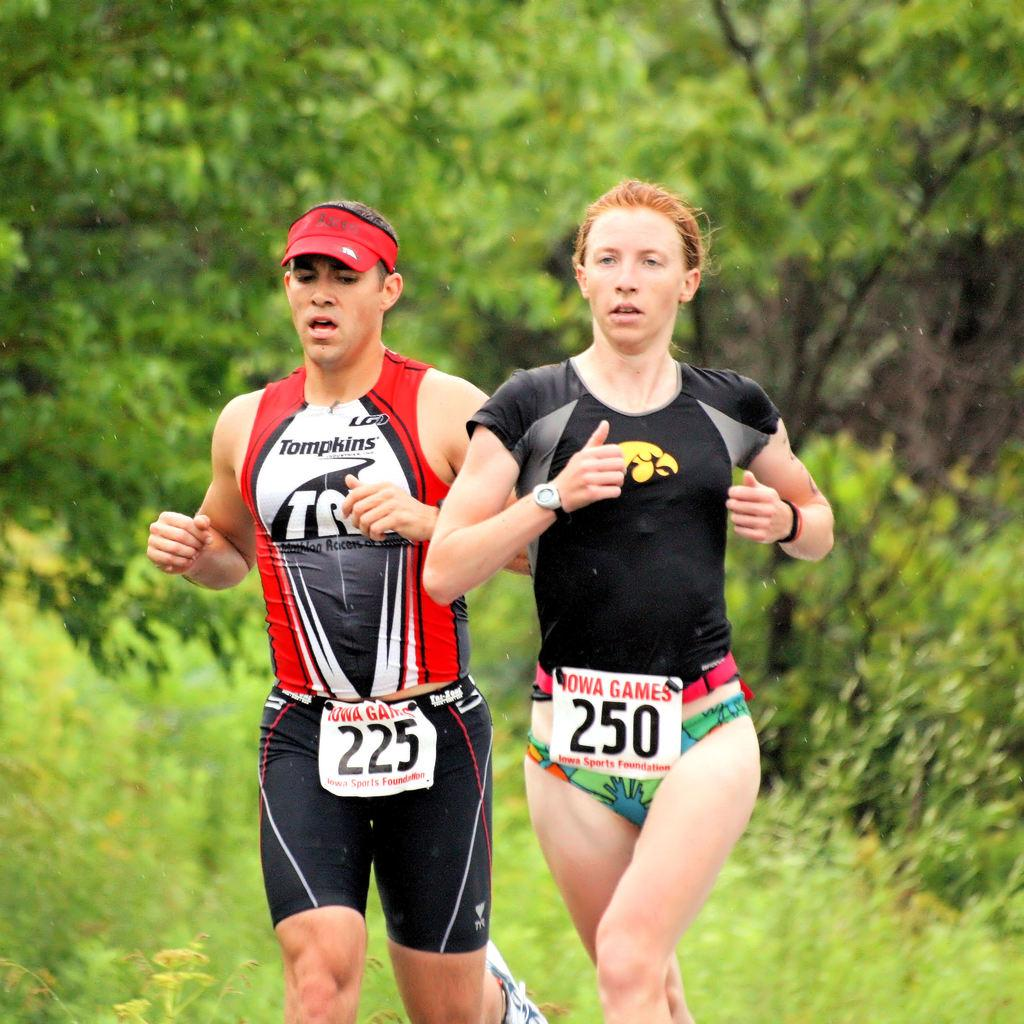<image>
Describe the image concisely. Runner number 250 is jogging alongside runner number 225. 